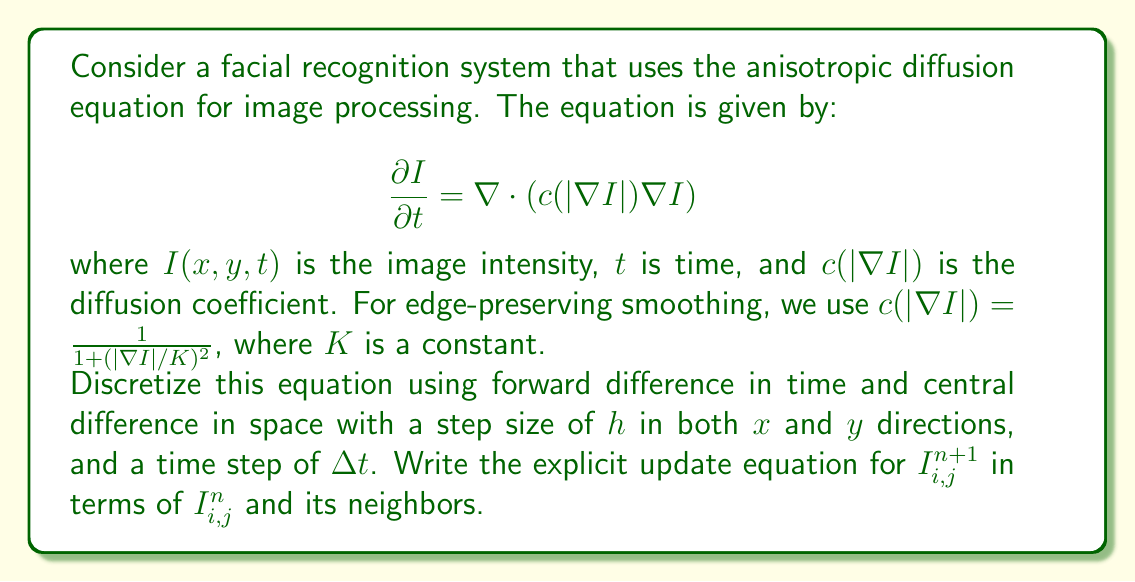Teach me how to tackle this problem. To solve this problem, we'll follow these steps:

1) First, let's expand the right-hand side of the anisotropic diffusion equation:

   $$\nabla \cdot (c(|\nabla I|)\nabla I) = \frac{\partial}{\partial x}(c\frac{\partial I}{\partial x}) + \frac{\partial}{\partial y}(c\frac{\partial I}{\partial y})$$

2) Now, we'll discretize each term:

   - Time derivative: $\frac{\partial I}{\partial t} \approx \frac{I_{i,j}^{n+1} - I_{i,j}^n}{\Delta t}$
   
   - Spatial derivatives:
     $\frac{\partial I}{\partial x} \approx \frac{I_{i+1,j}^n - I_{i-1,j}^n}{2h}$
     $\frac{\partial I}{\partial y} \approx \frac{I_{i,j+1}^n - I_{i,j-1}^n}{2h}$

   - Second derivatives:
     $\frac{\partial}{\partial x}(c\frac{\partial I}{\partial x}) \approx \frac{c_{i+1/2,j}(I_{i+1,j}^n - I_{i,j}^n) - c_{i-1/2,j}(I_{i,j}^n - I_{i-1,j}^n)}{h^2}$
     $\frac{\partial}{\partial y}(c\frac{\partial I}{\partial y}) \approx \frac{c_{i,j+1/2}(I_{i,j+1}^n - I_{i,j}^n) - c_{i,j-1/2}(I_{i,j}^n - I_{i,j-1}^n)}{h^2}$

3) The diffusion coefficients at half-grid points are approximated as:

   $c_{i+1/2,j} = \frac{1}{1 + (|\nabla I_{i+1/2,j}|/K)^2}$, where $|\nabla I_{i+1/2,j}| \approx \frac{|I_{i+1,j}^n - I_{i,j}^n|}{h}$

   Similarly for $c_{i-1/2,j}$, $c_{i,j+1/2}$, and $c_{i,j-1/2}$.

4) Substituting these discretizations into the original equation:

   $$\frac{I_{i,j}^{n+1} - I_{i,j}^n}{\Delta t} = \frac{c_{i+1/2,j}(I_{i+1,j}^n - I_{i,j}^n) - c_{i-1/2,j}(I_{i,j}^n - I_{i-1,j}^n)}{h^2} + \frac{c_{i,j+1/2}(I_{i,j+1}^n - I_{i,j}^n) - c_{i,j-1/2}(I_{i,j}^n - I_{i,j-1}^n)}{h^2}$$

5) Rearranging to solve for $I_{i,j}^{n+1}$:

   $$I_{i,j}^{n+1} = I_{i,j}^n + \frac{\Delta t}{h^2}[c_{i+1/2,j}(I_{i+1,j}^n - I_{i,j}^n) - c_{i-1/2,j}(I_{i,j}^n - I_{i-1,j}^n) + c_{i,j+1/2}(I_{i,j+1}^n - I_{i,j}^n) - c_{i,j-1/2}(I_{i,j}^n - I_{i,j-1}^n)]$$

This is the explicit update equation for the anisotropic diffusion process.
Answer: $$I_{i,j}^{n+1} = I_{i,j}^n + \frac{\Delta t}{h^2}[c_{i+1/2,j}(I_{i+1,j}^n - I_{i,j}^n) - c_{i-1/2,j}(I_{i,j}^n - I_{i-1,j}^n) + c_{i,j+1/2}(I_{i,j+1}^n - I_{i,j}^n) - c_{i,j-1/2}(I_{i,j}^n - I_{i,j-1}^n)]$$ 